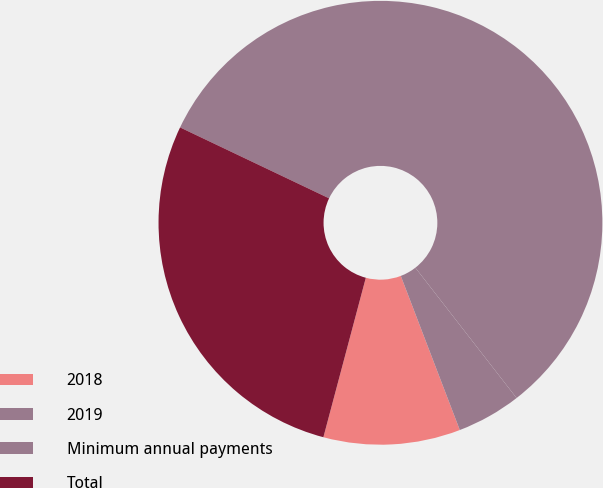<chart> <loc_0><loc_0><loc_500><loc_500><pie_chart><fcel>2018<fcel>2019<fcel>Minimum annual payments<fcel>Total<nl><fcel>9.96%<fcel>4.69%<fcel>57.42%<fcel>27.93%<nl></chart> 